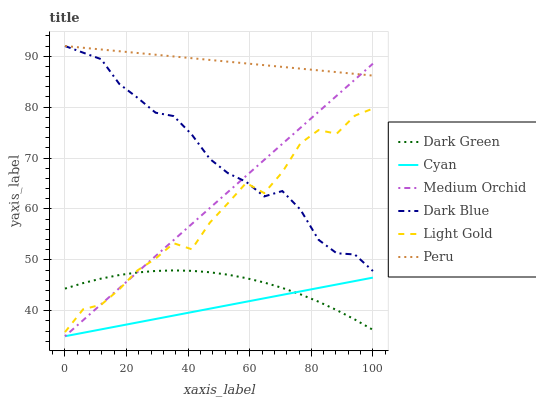Does Cyan have the minimum area under the curve?
Answer yes or no. Yes. Does Peru have the maximum area under the curve?
Answer yes or no. Yes. Does Dark Blue have the minimum area under the curve?
Answer yes or no. No. Does Dark Blue have the maximum area under the curve?
Answer yes or no. No. Is Peru the smoothest?
Answer yes or no. Yes. Is Light Gold the roughest?
Answer yes or no. Yes. Is Dark Blue the smoothest?
Answer yes or no. No. Is Dark Blue the roughest?
Answer yes or no. No. Does Dark Blue have the lowest value?
Answer yes or no. No. Does Peru have the highest value?
Answer yes or no. Yes. Does Cyan have the highest value?
Answer yes or no. No. Is Cyan less than Dark Blue?
Answer yes or no. Yes. Is Peru greater than Cyan?
Answer yes or no. Yes. Does Dark Blue intersect Light Gold?
Answer yes or no. Yes. Is Dark Blue less than Light Gold?
Answer yes or no. No. Is Dark Blue greater than Light Gold?
Answer yes or no. No. Does Cyan intersect Dark Blue?
Answer yes or no. No. 